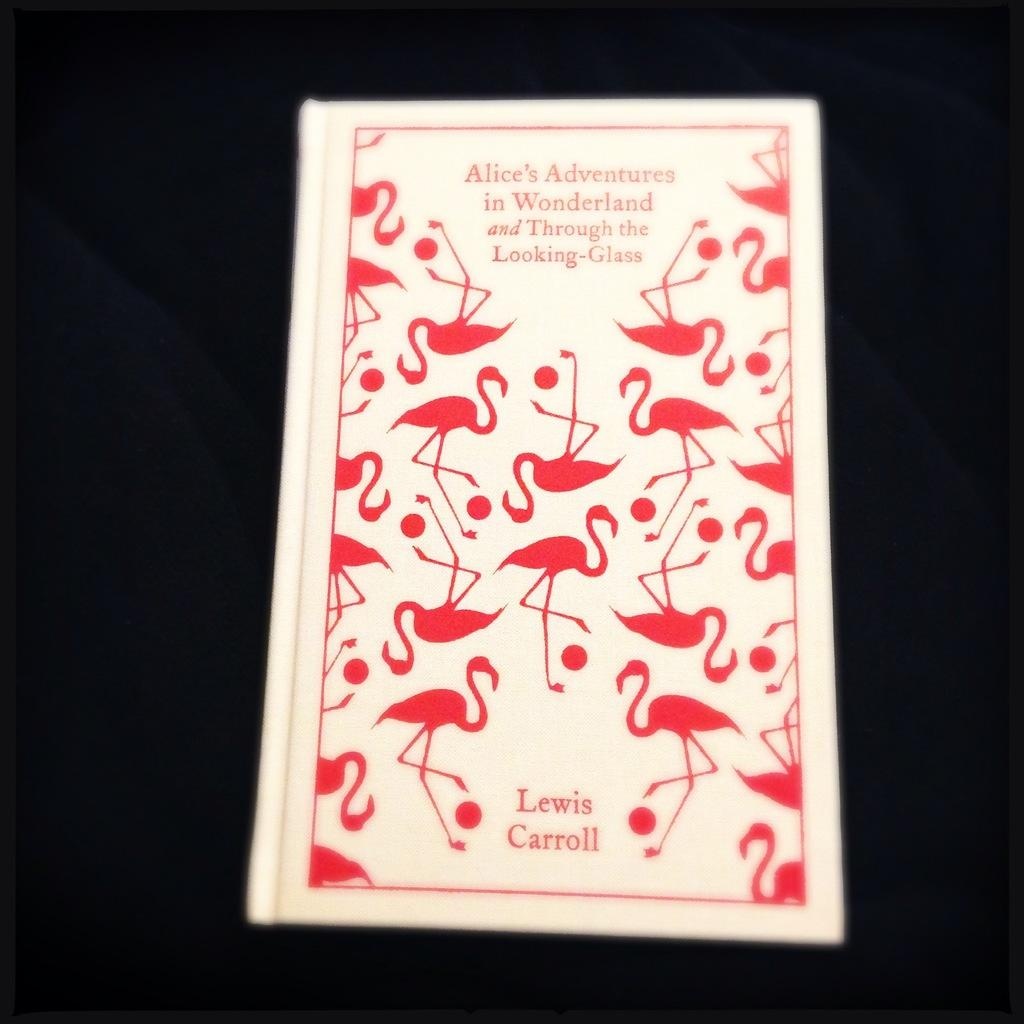Provide a one-sentence caption for the provided image. A novel pink and white cover of a Lewis Carroll book. 